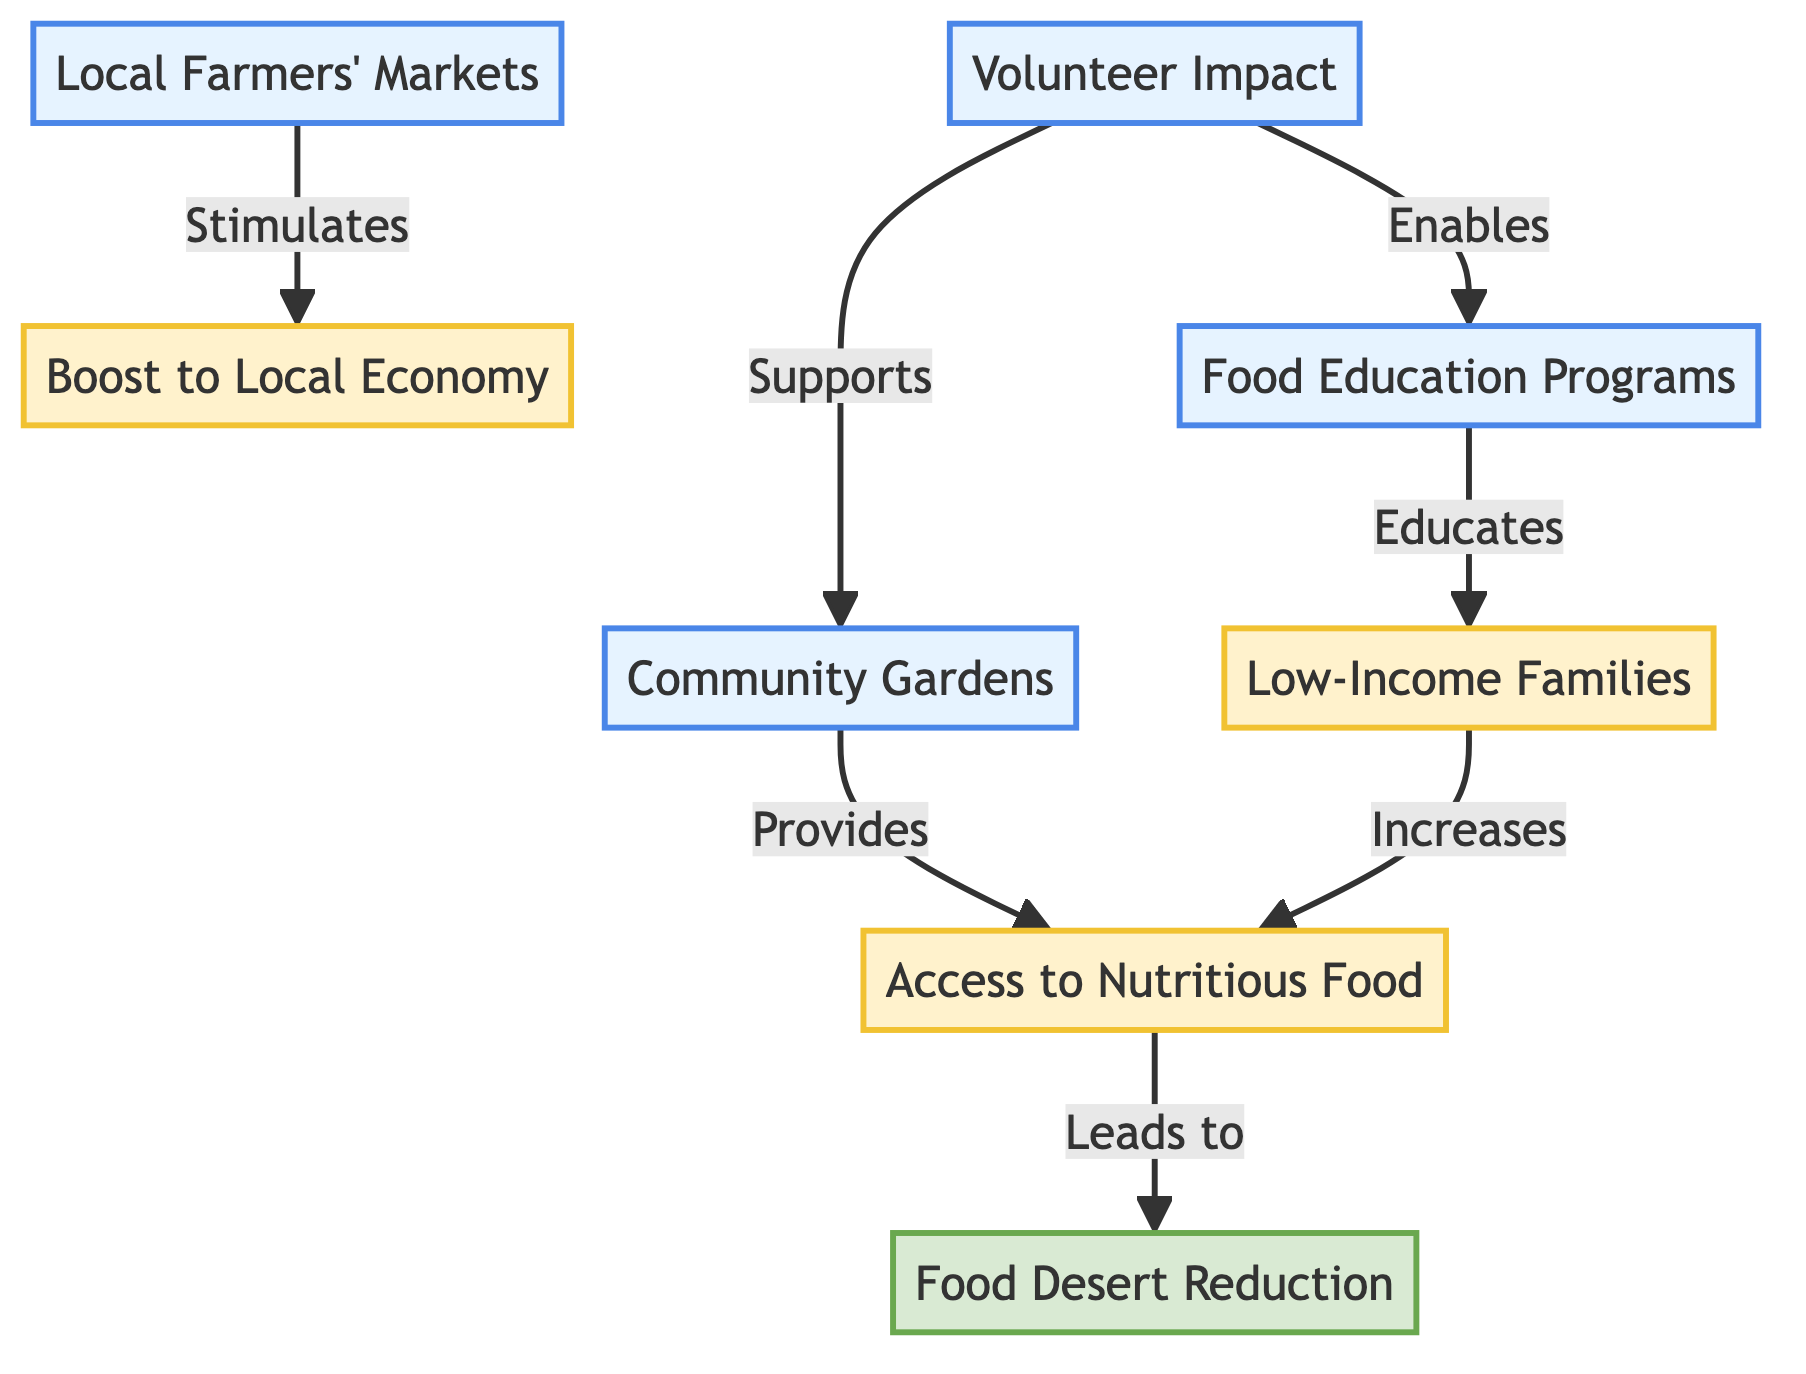What programs are listed in the diagram? The diagram lists three programs: Community Gardens, Food Education Programs, and Local Farmers' Markets.
Answer: Community Gardens, Food Education Programs, Local Farmers' Markets How many outcomes are shown in the diagram? The diagram shows three outcomes: Access to Nutritious Food, Low-Income Families, and Boost to Local Economy.
Answer: Three What is the relationship between Local Farmers' Markets and Boost to Local Economy? The diagram indicates that Local Farmers' Markets stimulates Boost to Local Economy.
Answer: Stimulates Which program provides Access to Nutritious Food? The diagram shows that Community Gardens provides Access to Nutritious Food.
Answer: Community Gardens What impact is achieved by Access to Nutritious Food? Access to Nutritious Food leads to Food Desert Reduction according to the diagram.
Answer: Food Desert Reduction Which two programs are supported by volunteers? Volunteers support Community Gardens and enable Food Education Programs, as shown in the diagram.
Answer: Community Gardens, Food Education Programs How does Food Education Programs connect to Low-Income Families? The diagram specifies that Food Education Programs educates Low-Income Families.
Answer: Educates What is the final impact that is connected to all programs? The final impact connected to all programs is Food Desert Reduction.
Answer: Food Desert Reduction Which node directly leads to Food Desert Reduction? Access to Nutritious Food is the node that directly leads to Food Desert Reduction.
Answer: Access to Nutritious Food 